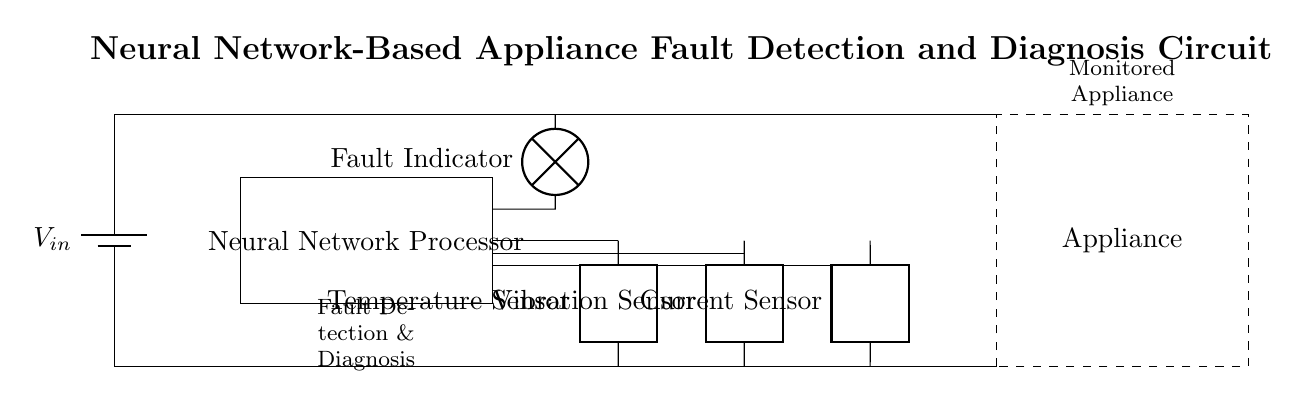What is the main function of the Neural Network Processor? The main function of the Neural Network Processor in this circuit is to process data from multiple sensors to detect and diagnose faults in the appliance.
Answer: Fault detection and diagnosis How many sensors are present in the circuit? There are three types of sensors in the circuit: a temperature sensor, a vibration sensor, and a current sensor. Counting them gives a total of three sensors.
Answer: Three What does the Fault Indicator represent? The Fault Indicator is a lamp symbol that visually indicates whether a fault has been detected in the appliance; it lights up when the neural network identifies an issue.
Answer: Fault Indicator How does the Neural Network Processor receive data from the sensors? The Neural Network Processor receives data from the sensors through direct connections depicted in the circuit diagram, allowing it to analyze sensor outputs for fault detection.
Answer: Through connections What are the inputs to the Neural Network Processor? The inputs to the Neural Network Processor are the outputs from the temperature, vibration, and current sensors, which provide necessary data for analysis.
Answer: Sensor outputs What is the power supply voltage source indicated in the circuit? The power supply voltage is indicated as \( V_{in} \) in the circuit, which is the input voltage source providing power for the entire circuit operation.
Answer: \( V_{in} \) What is the role of the dashed rectangle in the diagram? The dashed rectangle represents the monitored appliance, signifying where the fault detection system is applied and which appliance is being monitored for issues.
Answer: Monitored appliance 